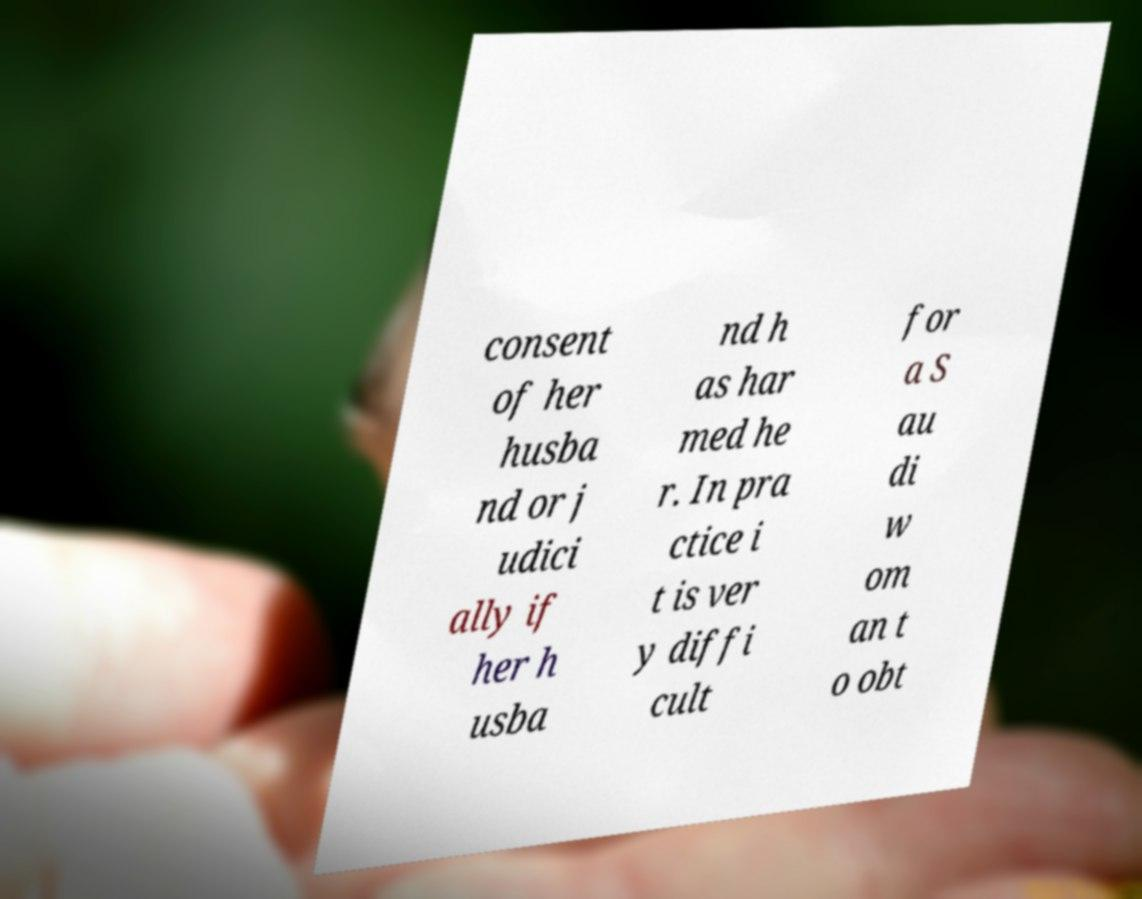Could you assist in decoding the text presented in this image and type it out clearly? consent of her husba nd or j udici ally if her h usba nd h as har med he r. In pra ctice i t is ver y diffi cult for a S au di w om an t o obt 